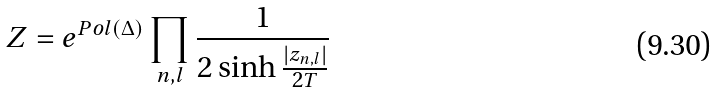Convert formula to latex. <formula><loc_0><loc_0><loc_500><loc_500>Z = e ^ { P o l ( \Delta ) } \prod _ { n , l } \frac { 1 } { 2 \sinh \frac { | z _ { n , l } | } { 2 T } }</formula> 